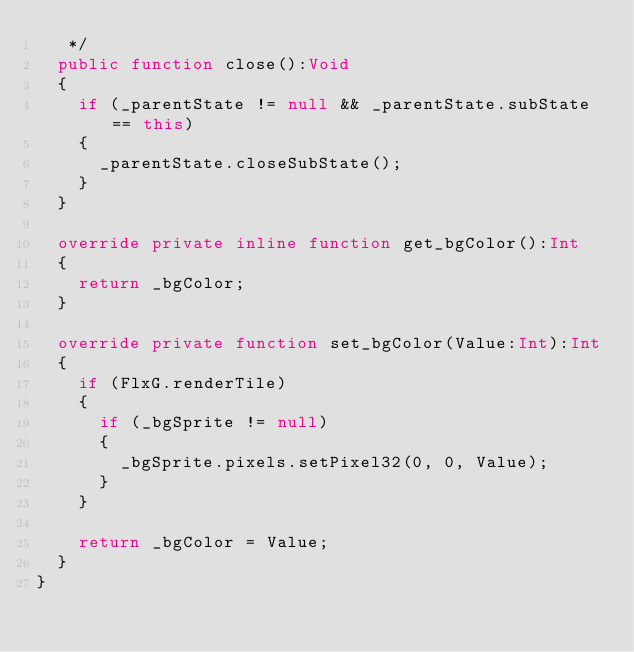Convert code to text. <code><loc_0><loc_0><loc_500><loc_500><_Haxe_>	 */ 
	public function close():Void
	{
		if (_parentState != null && _parentState.subState == this) 
		{ 
			_parentState.closeSubState(); 
		}
	}
	
	override private inline function get_bgColor():Int
	{
		return _bgColor;
	}
	
	override private function set_bgColor(Value:Int):Int
	{
		if (FlxG.renderTile)
		{
			if (_bgSprite != null)
			{
				_bgSprite.pixels.setPixel32(0, 0, Value);
			}
		}
		
		return _bgColor = Value;
	}
}</code> 